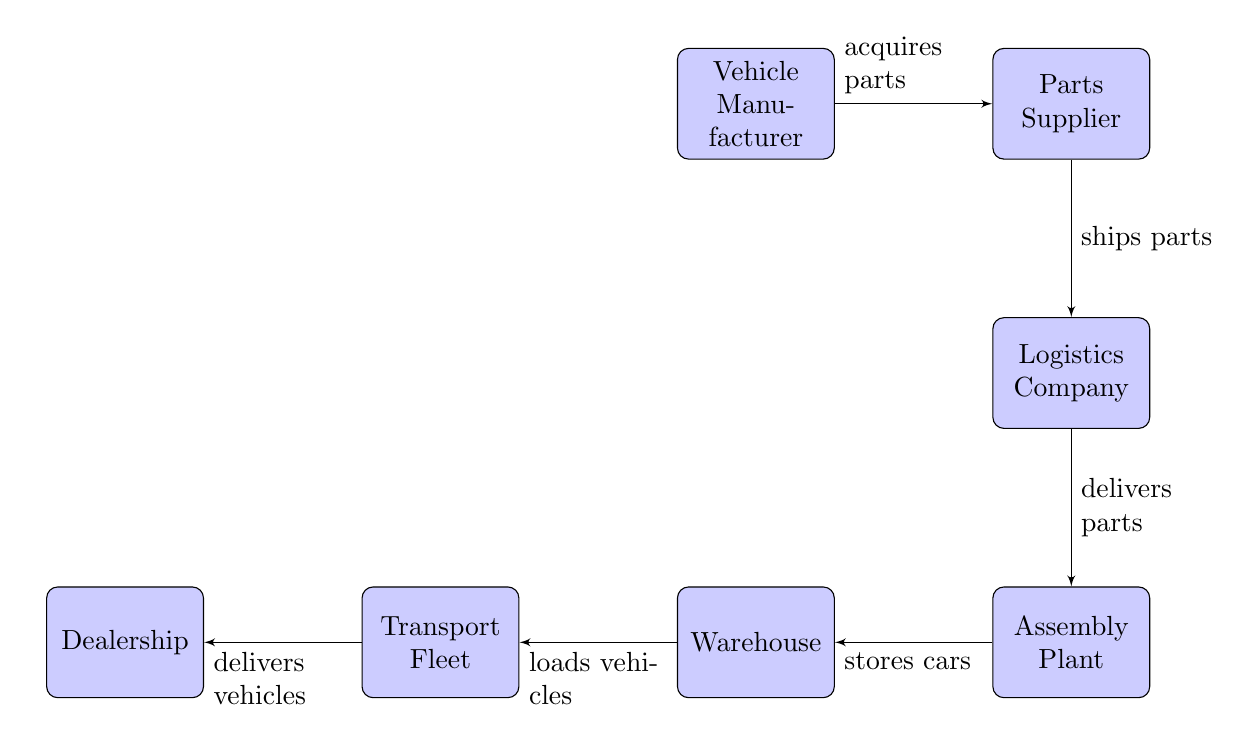What is the first node in the supply chain? The first node in the diagram is "Vehicle Manufacturer," which is positioned at the top of the visual flow, indicating it is the starting point for the supply chain.
Answer: Vehicle Manufacturer How many nodes are present in the diagram? Counting all the blocks in the diagram, there are six nodes: Vehicle Manufacturer, Parts Supplier, Logistics Company, Assembly Plant, Warehouse, and Dealership.
Answer: 6 What does the Parts Supplier do? The Parts Supplier is connected to the Vehicle Manufacturer and is responsible for shipping parts, as indicated by the label on the arrow connecting them.
Answer: Ships parts Which node stores cars? In the flow of the diagram, the "Assembly Plant" is the node responsible for storing cars, as denoted by the connecting edge that indicates this function.
Answer: Assembly Plant What is delivered from the Transport Fleet to the Dealership? The arrow leading from the Transport Fleet to the Dealership describes the action of delivering vehicles, which signifies the final step in the supply chain.
Answer: Vehicles What is the last step in the supply chain process? According to the diagram, the last step in the supply chain process involves the Transport Fleet delivering vehicles to the Dealership, completing the supply chain cycle.
Answer: Delivers vehicles How do the logistics and assembly nodes connect? The logistics node connects to the assembly node with a flow indicating that the logistics company delivers parts to the assembly plant, establishing the relationship between these two essential steps.
Answer: Delivers parts What node is responsible for loading vehicles? The "Transport Fleet" is designated as the node that loads vehicles based on the labeled connection from the "Warehouse" node that signifies this action.
Answer: Transport Fleet 